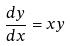<formula> <loc_0><loc_0><loc_500><loc_500>\frac { d y } { d x } = x y</formula> 